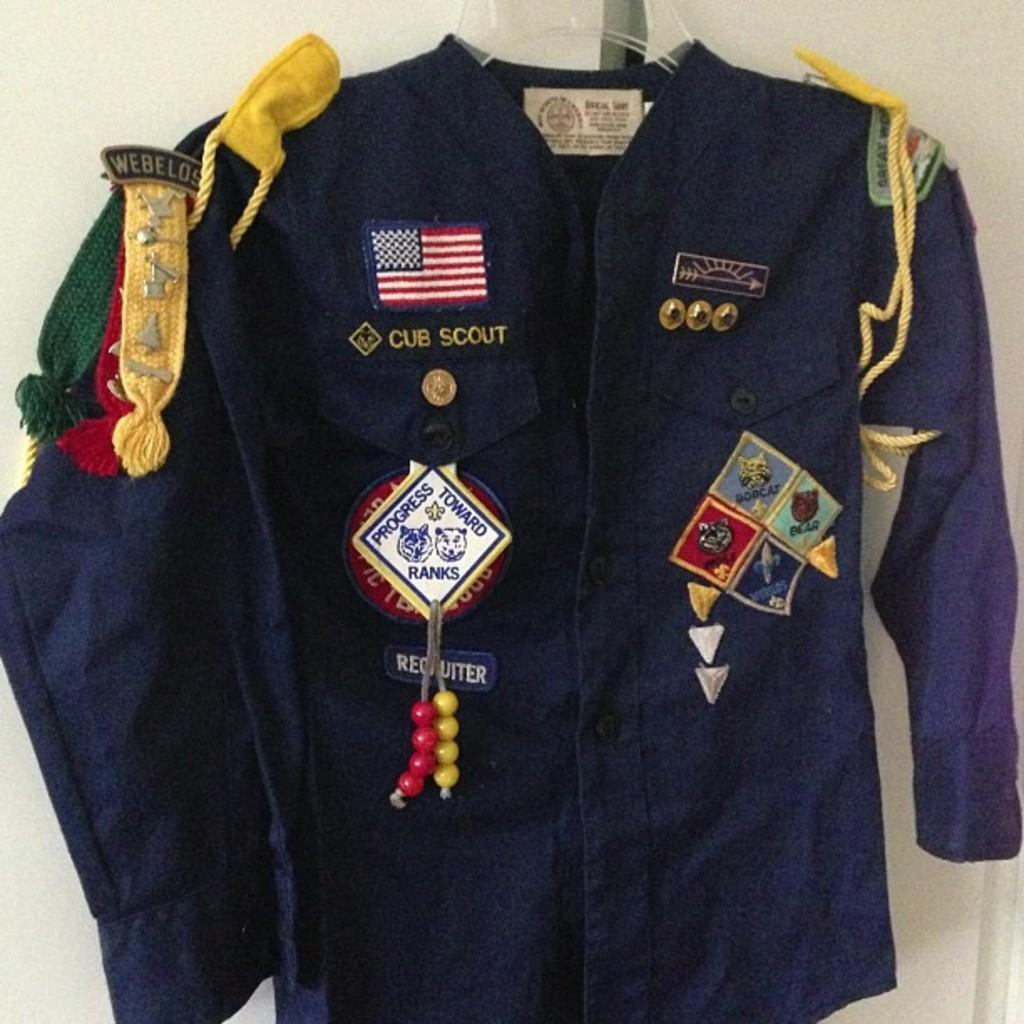<image>
Give a short and clear explanation of the subsequent image. Blue jacket with the words "Progress Towards Ranks" on it. 